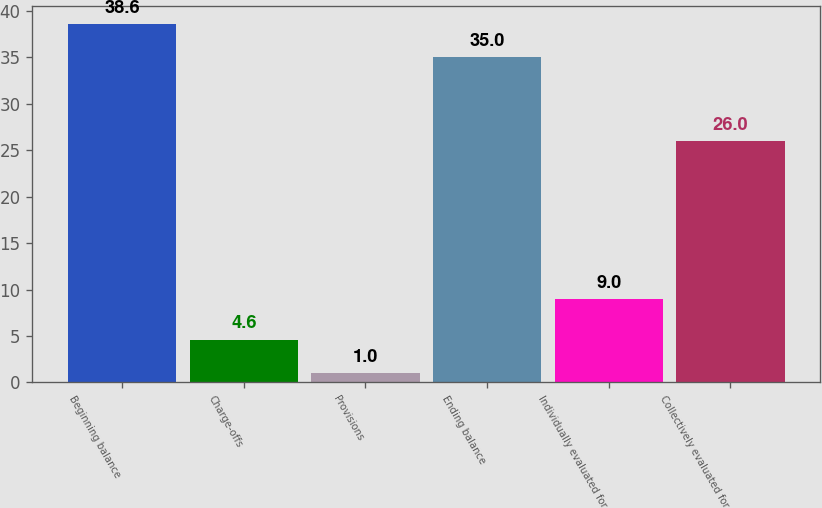Convert chart. <chart><loc_0><loc_0><loc_500><loc_500><bar_chart><fcel>Beginning balance<fcel>Charge-offs<fcel>Provisions<fcel>Ending balance<fcel>Individually evaluated for<fcel>Collectively evaluated for<nl><fcel>38.6<fcel>4.6<fcel>1<fcel>35<fcel>9<fcel>26<nl></chart> 